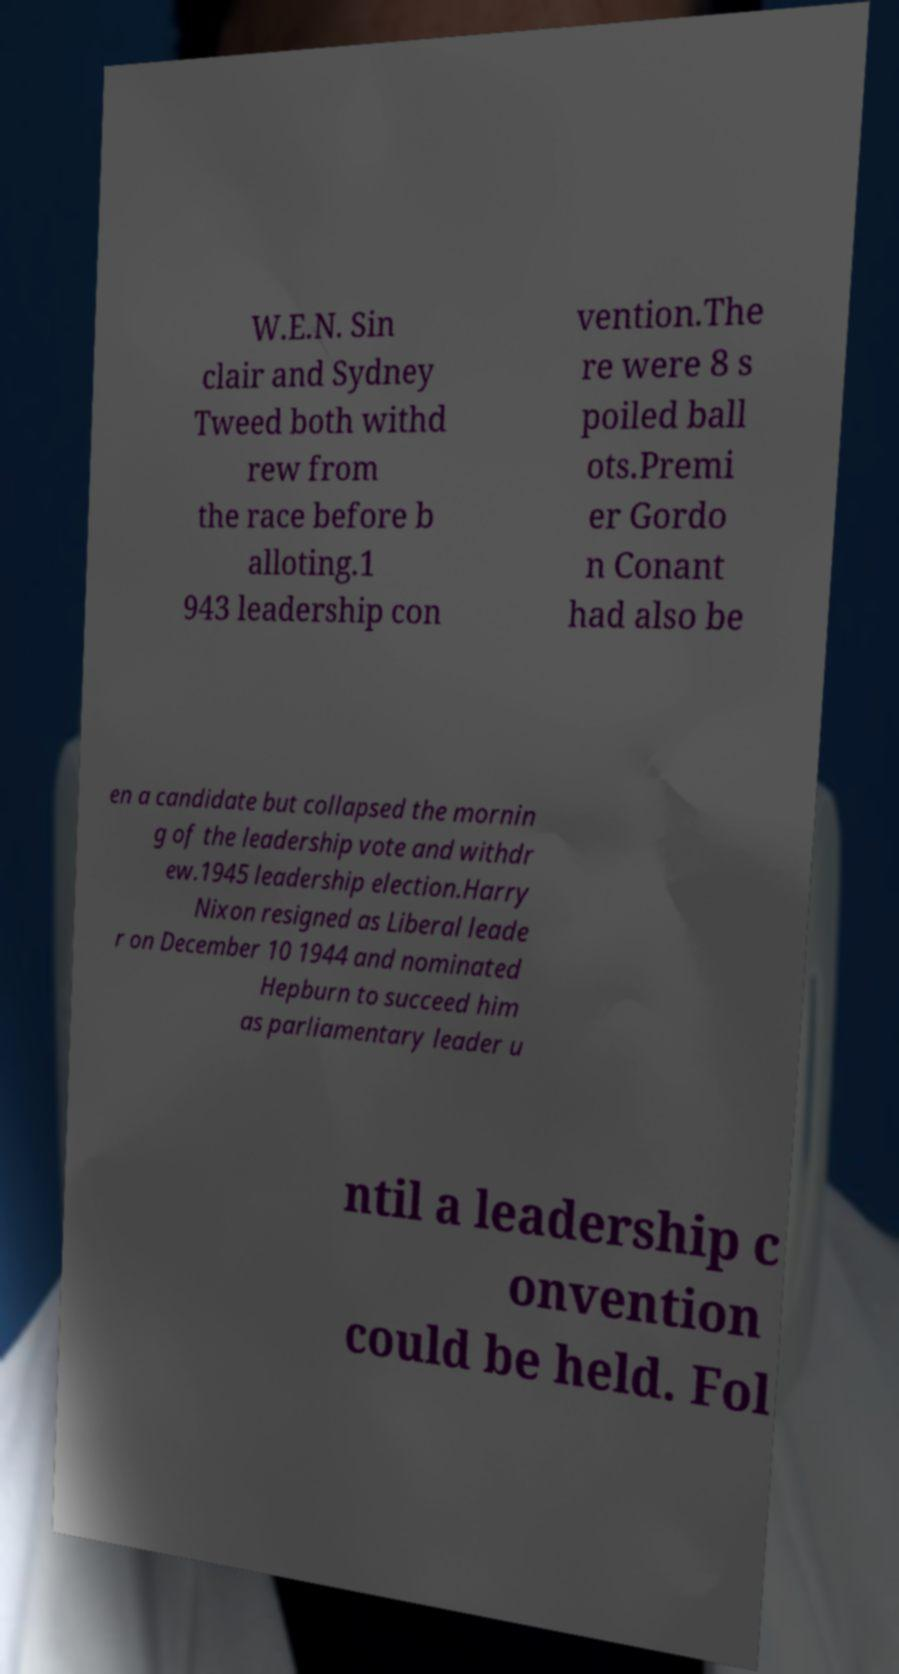For documentation purposes, I need the text within this image transcribed. Could you provide that? W.E.N. Sin clair and Sydney Tweed both withd rew from the race before b alloting.1 943 leadership con vention.The re were 8 s poiled ball ots.Premi er Gordo n Conant had also be en a candidate but collapsed the mornin g of the leadership vote and withdr ew.1945 leadership election.Harry Nixon resigned as Liberal leade r on December 10 1944 and nominated Hepburn to succeed him as parliamentary leader u ntil a leadership c onvention could be held. Fol 